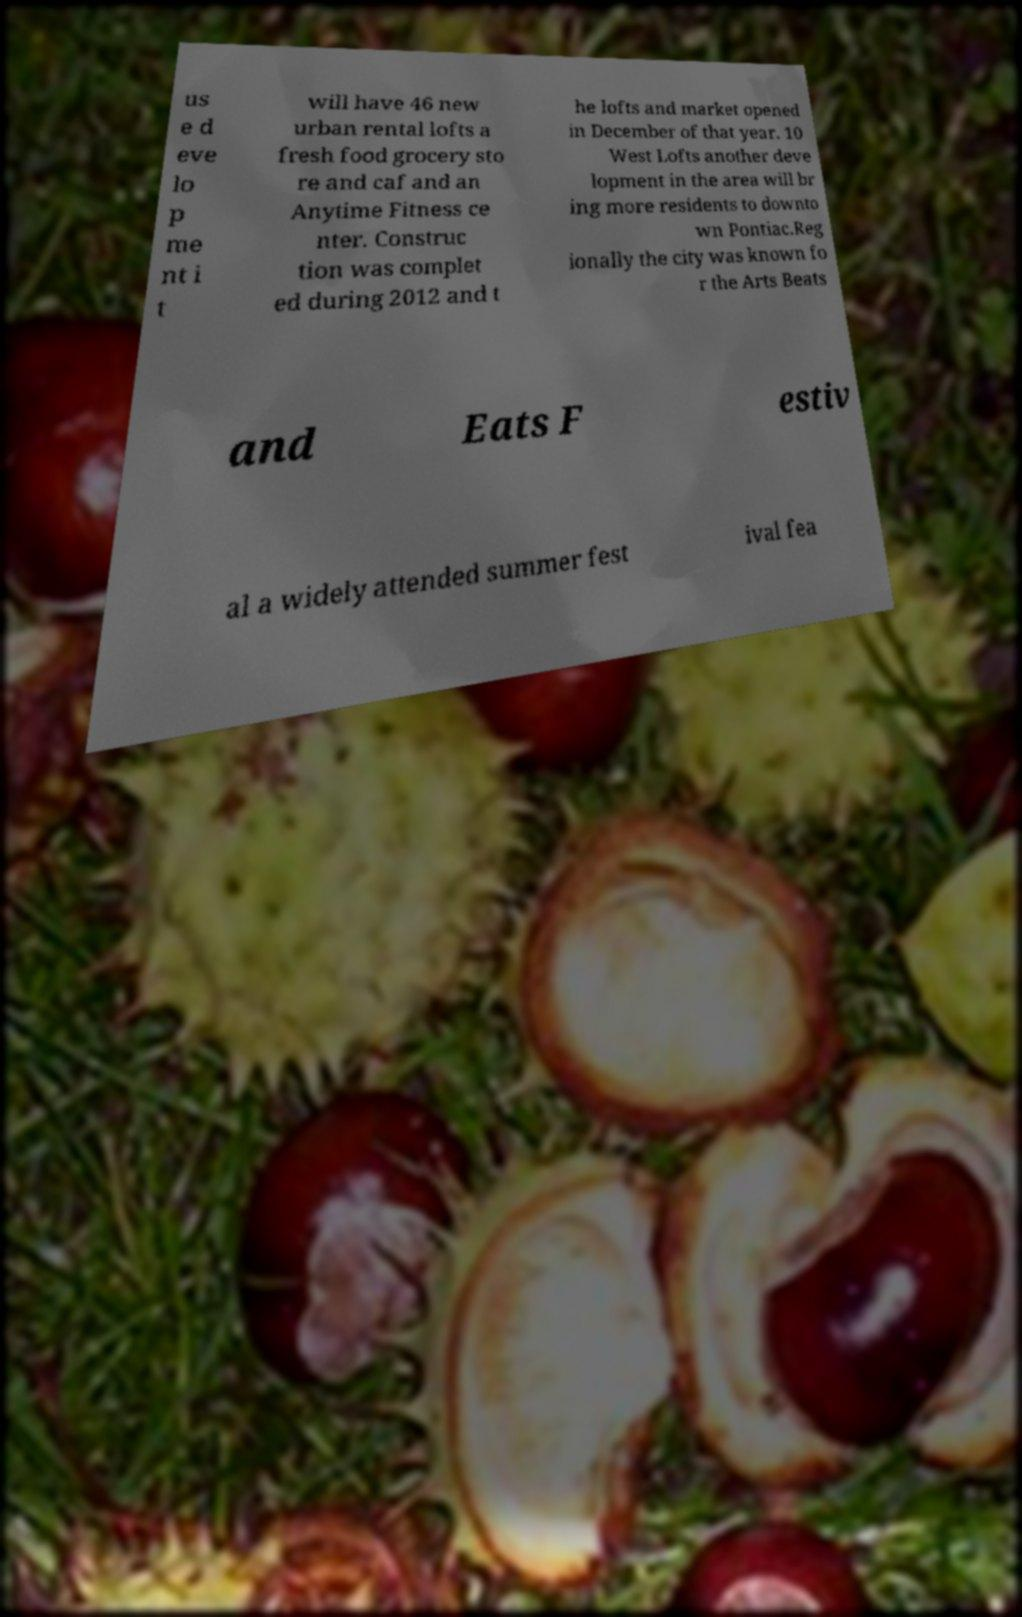Could you assist in decoding the text presented in this image and type it out clearly? us e d eve lo p me nt i t will have 46 new urban rental lofts a fresh food grocery sto re and caf and an Anytime Fitness ce nter. Construc tion was complet ed during 2012 and t he lofts and market opened in December of that year. 10 West Lofts another deve lopment in the area will br ing more residents to downto wn Pontiac.Reg ionally the city was known fo r the Arts Beats and Eats F estiv al a widely attended summer fest ival fea 